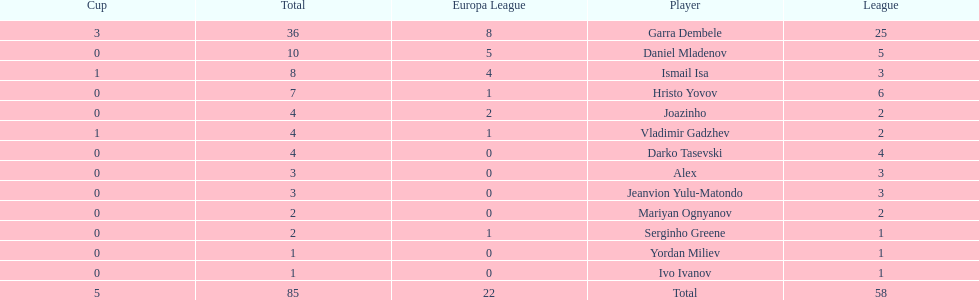Which total is higher, the europa league total or the league total? League. 